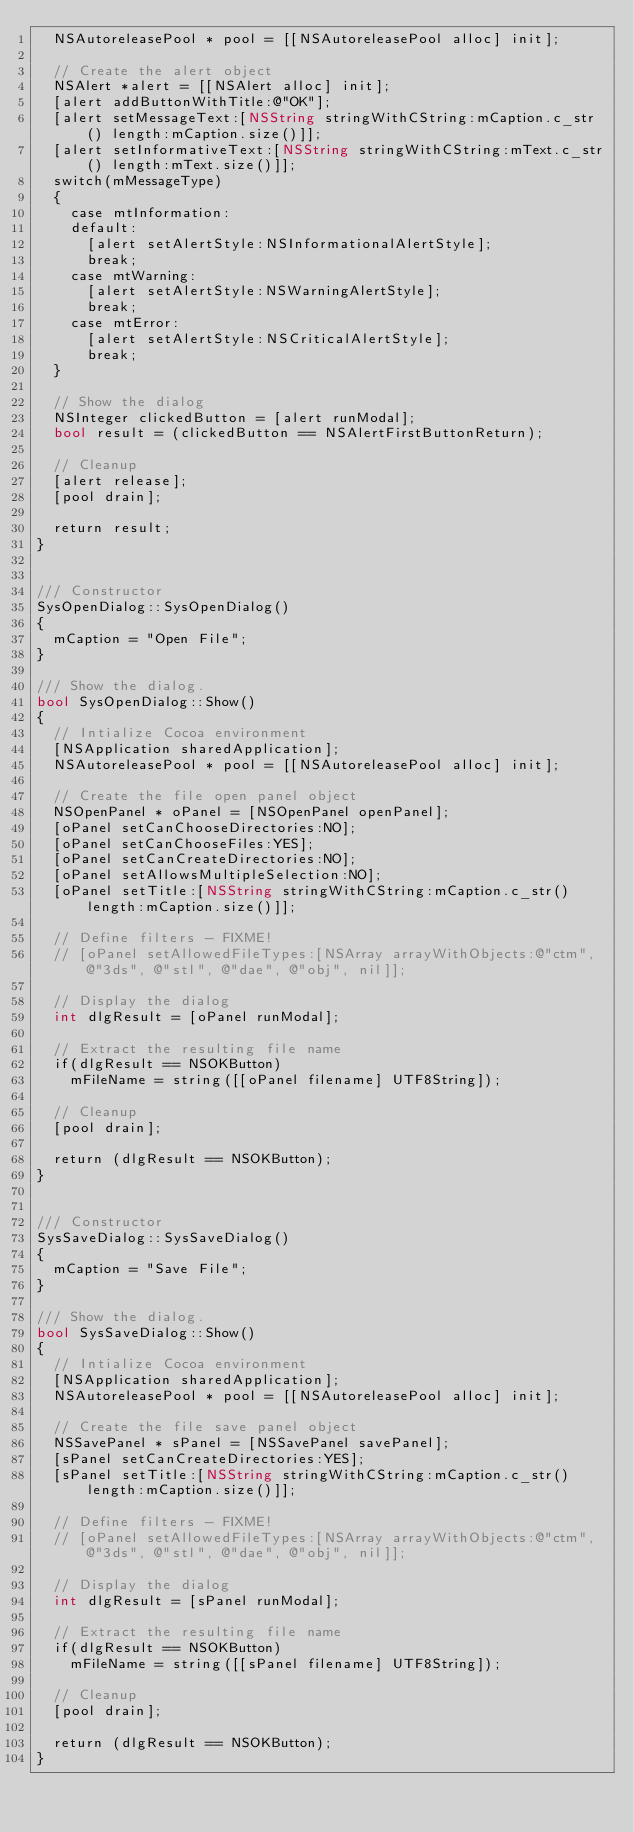Convert code to text. <code><loc_0><loc_0><loc_500><loc_500><_ObjectiveC_>  NSAutoreleasePool * pool = [[NSAutoreleasePool alloc] init];

  // Create the alert object
  NSAlert *alert = [[NSAlert alloc] init];
  [alert addButtonWithTitle:@"OK"];
  [alert setMessageText:[NSString stringWithCString:mCaption.c_str() length:mCaption.size()]];
  [alert setInformativeText:[NSString stringWithCString:mText.c_str() length:mText.size()]];
  switch(mMessageType)
  {
    case mtInformation:
    default:
      [alert setAlertStyle:NSInformationalAlertStyle];
      break;
    case mtWarning:
      [alert setAlertStyle:NSWarningAlertStyle];
      break;
    case mtError:
      [alert setAlertStyle:NSCriticalAlertStyle];
      break;
  }

  // Show the dialog
  NSInteger clickedButton = [alert runModal];
  bool result = (clickedButton == NSAlertFirstButtonReturn);

  // Cleanup
  [alert release];
  [pool drain];

  return result;
}


/// Constructor
SysOpenDialog::SysOpenDialog()
{
  mCaption = "Open File";
}

/// Show the dialog.
bool SysOpenDialog::Show()
{
  // Intialize Cocoa environment
  [NSApplication sharedApplication];
  NSAutoreleasePool * pool = [[NSAutoreleasePool alloc] init];

  // Create the file open panel object
  NSOpenPanel * oPanel = [NSOpenPanel openPanel];
  [oPanel setCanChooseDirectories:NO];
  [oPanel setCanChooseFiles:YES];
  [oPanel setCanCreateDirectories:NO];
  [oPanel setAllowsMultipleSelection:NO];
  [oPanel setTitle:[NSString stringWithCString:mCaption.c_str() length:mCaption.size()]];

  // Define filters - FIXME!
  // [oPanel setAllowedFileTypes:[NSArray arrayWithObjects:@"ctm", @"3ds", @"stl", @"dae", @"obj", nil]];

  // Display the dialog
  int dlgResult = [oPanel runModal];

  // Extract the resulting file name
  if(dlgResult == NSOKButton)
    mFileName = string([[oPanel filename] UTF8String]);

  // Cleanup
  [pool drain];

  return (dlgResult == NSOKButton);
}


/// Constructor
SysSaveDialog::SysSaveDialog()
{
  mCaption = "Save File";
}

/// Show the dialog.
bool SysSaveDialog::Show()
{
  // Intialize Cocoa environment
  [NSApplication sharedApplication];
  NSAutoreleasePool * pool = [[NSAutoreleasePool alloc] init];

  // Create the file save panel object
  NSSavePanel * sPanel = [NSSavePanel savePanel];
  [sPanel setCanCreateDirectories:YES];
  [sPanel setTitle:[NSString stringWithCString:mCaption.c_str() length:mCaption.size()]];

  // Define filters - FIXME!
  // [oPanel setAllowedFileTypes:[NSArray arrayWithObjects:@"ctm", @"3ds", @"stl", @"dae", @"obj", nil]];

  // Display the dialog
  int dlgResult = [sPanel runModal];

  // Extract the resulting file name
  if(dlgResult == NSOKButton)
    mFileName = string([[sPanel filename] UTF8String]);

  // Cleanup
  [pool drain];

  return (dlgResult == NSOKButton);
}
</code> 